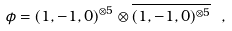<formula> <loc_0><loc_0><loc_500><loc_500>\phi = ( 1 , - 1 , 0 ) ^ { \otimes 5 } \otimes \overline { ( 1 , - 1 , 0 ) ^ { \otimes 5 } } \ ,</formula> 